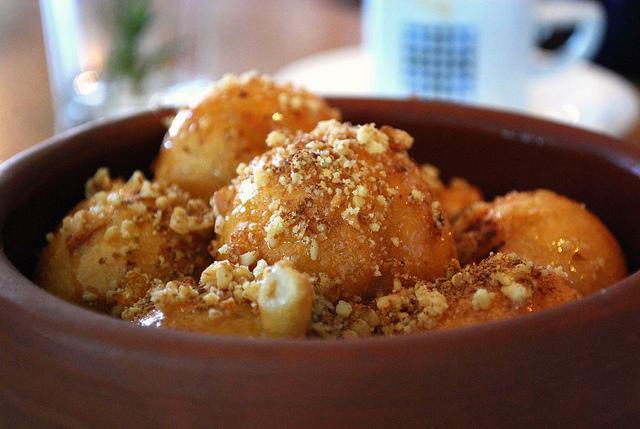How many cups are there?
Give a very brief answer. 2. How many donuts are in the picture?
Give a very brief answer. 5. 